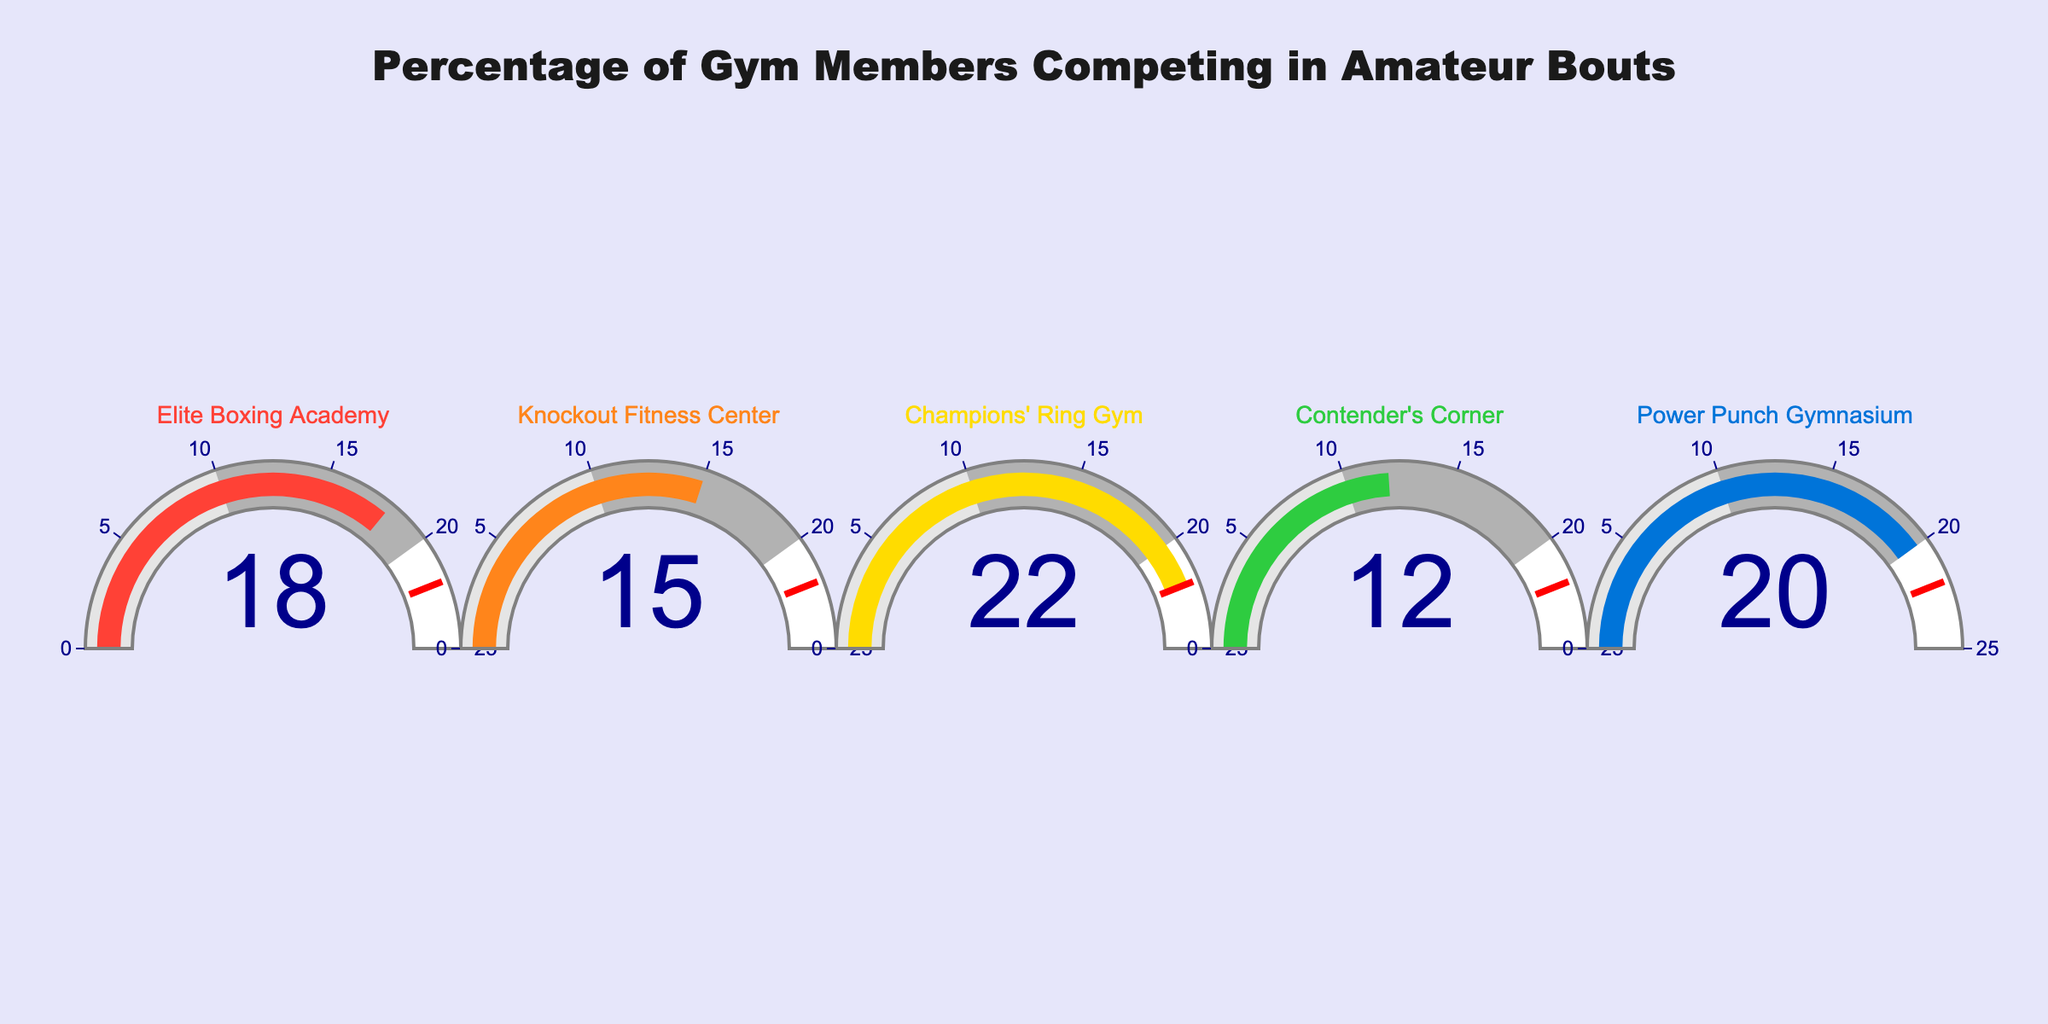What is the highest percentage of gym members competing in amateur bouts among the gyms? The highest percentage can be seen in the gauge chart with the maximum value displayed on the dial. In this case, the Champions' Ring Gym has the highest percentage at 22%.
Answer: 22% What is the difference in the percentage of members competing in amateur bouts between Champions' Ring Gym and Knockout Fitness Center? To find the difference, subtract the lower percentage value from the higher one: 22% (Champions' Ring Gym) - 15% (Knockout Fitness Center) = 7%.
Answer: 7% Which gym has the lowest percentage of members competing in amateur bouts? The gym with the lowest percentage is identified by the gauge chart with the smallest number on its dial. In this case, Contender's Corner has the lowest percentage at 12%.
Answer: Contender's Corner What is the sum of percentages of gym members who compete in amateur bouts from Elite Boxing Academy and Power Punch Gymnasium? To find the sum, add the two given percentages: 18% (Elite Boxing Academy) + 20% (Power Punch Gymnasium) = 38%.
Answer: 38% Are there any gyms with an equal number of competing members? Review each gauge chart; there is no equal number on the dials. Each gym has a unique percentage of members competing in amateur bouts.
Answer: No Which gym is placed in the middle in terms of percentage of members competing in amateur bouts? Sort the percentages in ascending order: 12% (Contender's Corner), 15% (Knockout Fitness Center), 18% (Elite Boxing Academy), 20% (Power Punch Gymnasium), 22% (Champions' Ring Gym). The middle percentage is 18%, which corresponds to Elite Boxing Academy.
Answer: Elite Boxing Academy What is the average percentage of gym members competing in amateur bouts across all gyms? To get the average, sum the percentages of all gyms and then divide by the number of gyms. Sum: 18% + 15% + 22% + 12% + 20% = 87%. Average: 87% / 5 = 17.4%.
Answer: 17.4% Which gym is closest to the average percentage of members competing in amateur bouts? The average percentage is 17.4%. The percentages of the gyms are: Elite Boxing Academy (18), Knockout Fitness Center (15), Champions' Ring Gym (22), Contender's Corner (12), Power Punch Gymnasium (20). Elite Boxing Academy at 18% is the closest to 17.4%.
Answer: Elite Boxing Academy By how much does Champions' Ring Gym exceed the gym with the second-highest percentage? The second-highest percentage is 20% (Power Punch Gymnasium). The difference is 22% (Champions' Ring Gym) - 20% (Power Punch Gymnasium) = 2%.
Answer: 2% 